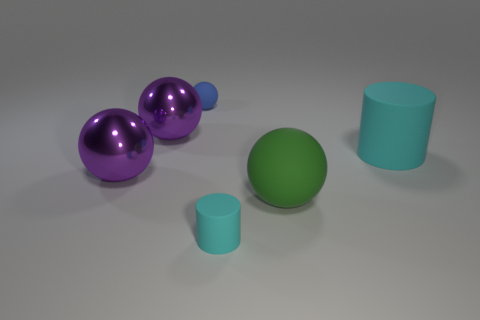Add 1 green matte objects. How many objects exist? 7 Subtract all cylinders. How many objects are left? 4 Subtract 0 gray spheres. How many objects are left? 6 Subtract all tiny yellow shiny things. Subtract all small blue spheres. How many objects are left? 5 Add 4 small cyan objects. How many small cyan objects are left? 5 Add 5 large rubber spheres. How many large rubber spheres exist? 6 